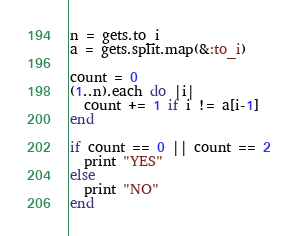<code> <loc_0><loc_0><loc_500><loc_500><_Ruby_>n = gets.to_i
a = gets.split.map(&:to_i)
 
count = 0
(1..n).each do |i|
  count += 1 if i != a[i-1]
end
 
if count == 0 || count == 2
  print "YES"
else
  print "NO"
end</code> 